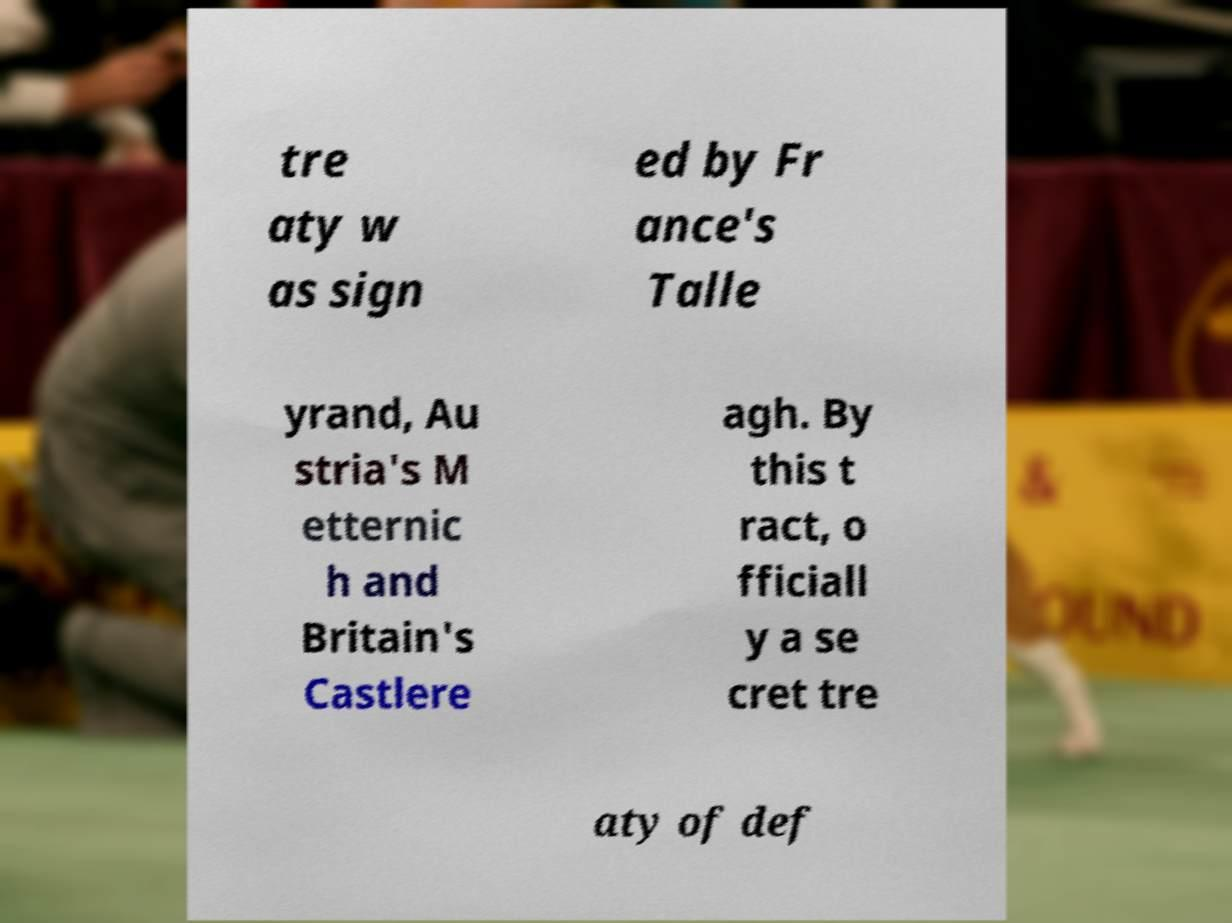Could you extract and type out the text from this image? tre aty w as sign ed by Fr ance's Talle yrand, Au stria's M etternic h and Britain's Castlere agh. By this t ract, o fficiall y a se cret tre aty of def 